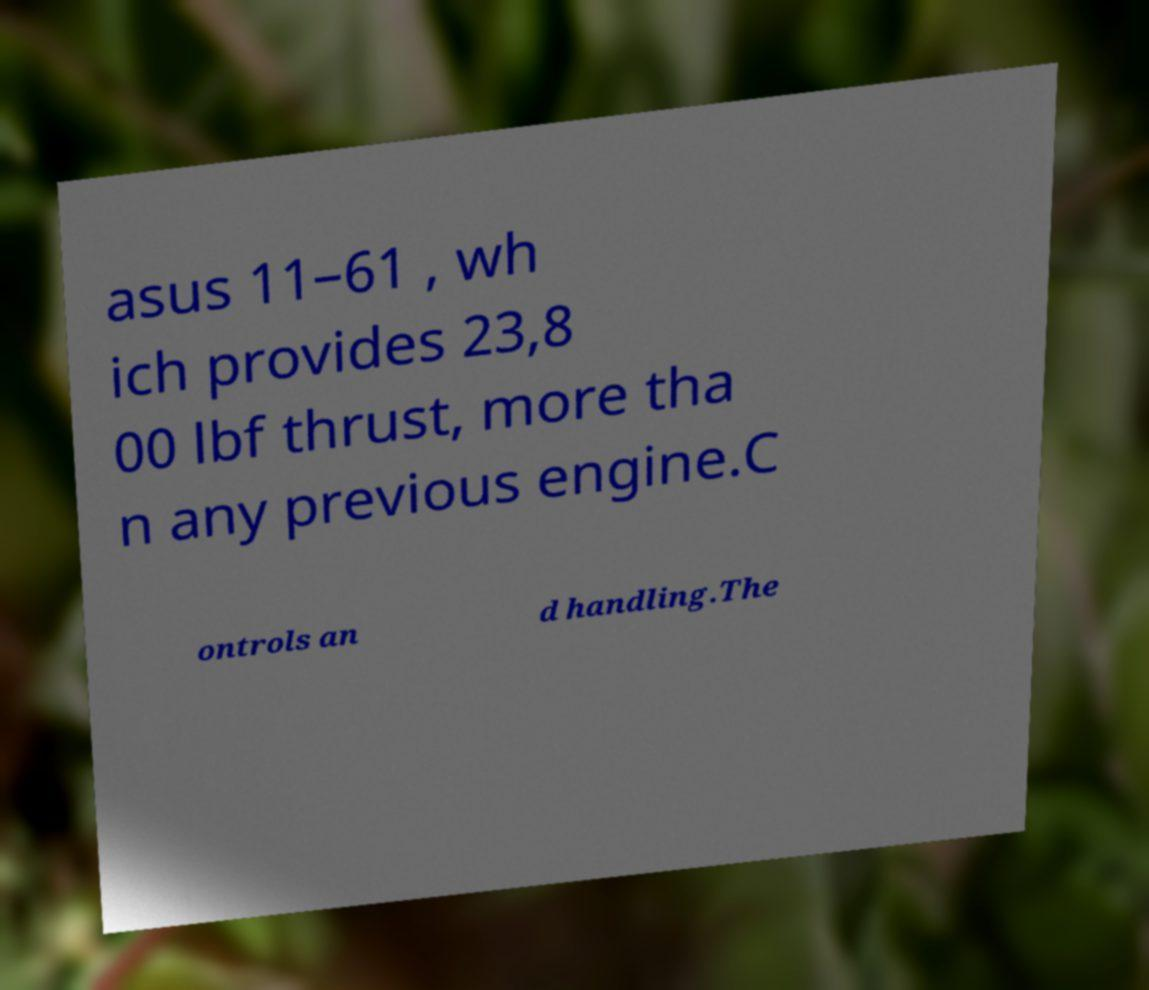For documentation purposes, I need the text within this image transcribed. Could you provide that? asus 11–61 , wh ich provides 23,8 00 lbf thrust, more tha n any previous engine.C ontrols an d handling.The 